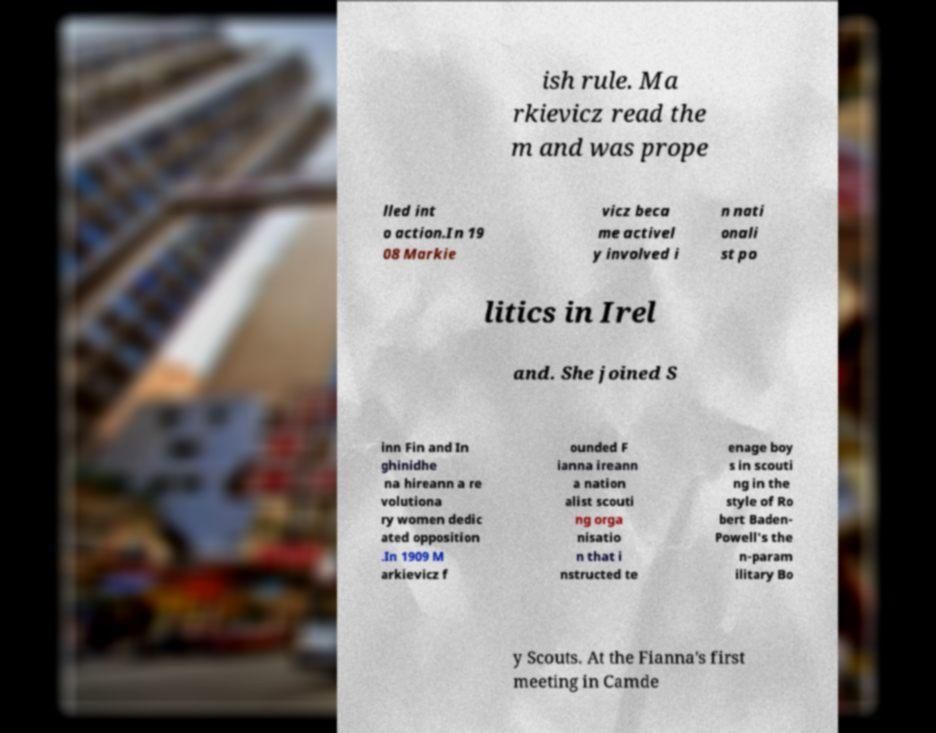Can you accurately transcribe the text from the provided image for me? ish rule. Ma rkievicz read the m and was prope lled int o action.In 19 08 Markie vicz beca me activel y involved i n nati onali st po litics in Irel and. She joined S inn Fin and In ghinidhe na hireann a re volutiona ry women dedic ated opposition .In 1909 M arkievicz f ounded F ianna ireann a nation alist scouti ng orga nisatio n that i nstructed te enage boy s in scouti ng in the style of Ro bert Baden- Powell's the n-param ilitary Bo y Scouts. At the Fianna's first meeting in Camde 